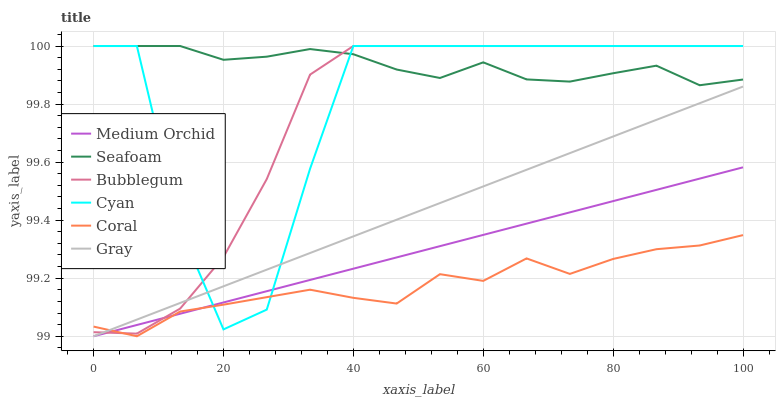Does Coral have the minimum area under the curve?
Answer yes or no. Yes. Does Seafoam have the maximum area under the curve?
Answer yes or no. Yes. Does Medium Orchid have the minimum area under the curve?
Answer yes or no. No. Does Medium Orchid have the maximum area under the curve?
Answer yes or no. No. Is Gray the smoothest?
Answer yes or no. Yes. Is Cyan the roughest?
Answer yes or no. Yes. Is Coral the smoothest?
Answer yes or no. No. Is Coral the roughest?
Answer yes or no. No. Does Gray have the lowest value?
Answer yes or no. Yes. Does Seafoam have the lowest value?
Answer yes or no. No. Does Cyan have the highest value?
Answer yes or no. Yes. Does Medium Orchid have the highest value?
Answer yes or no. No. Is Gray less than Seafoam?
Answer yes or no. Yes. Is Seafoam greater than Medium Orchid?
Answer yes or no. Yes. Does Bubblegum intersect Cyan?
Answer yes or no. Yes. Is Bubblegum less than Cyan?
Answer yes or no. No. Is Bubblegum greater than Cyan?
Answer yes or no. No. Does Gray intersect Seafoam?
Answer yes or no. No. 